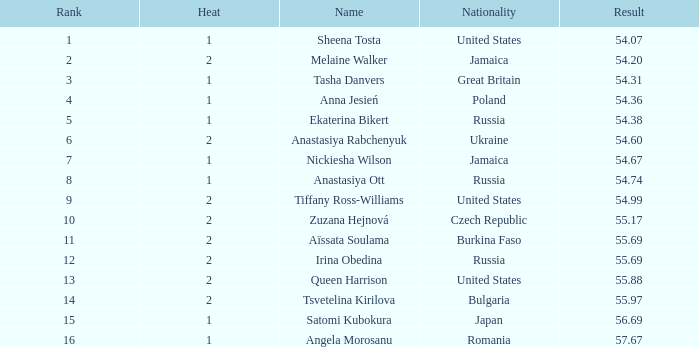Which Nationality has a Heat smaller than 2, and a Rank of 15? Japan. 